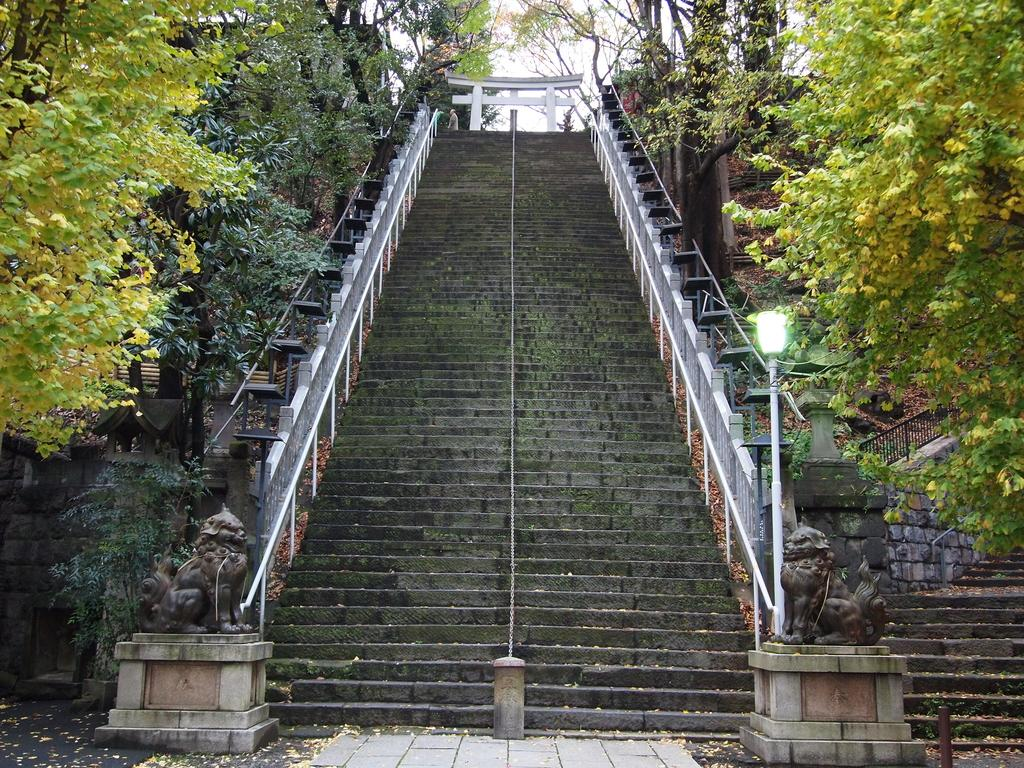What type of structure can be seen in the image? There are stairs in the image, which suggests a building or multi-level structure. What material is used for the rods in the image? Iron rods are present in the image. What is the purpose of the pole in the image? The pole's purpose is not explicitly stated, but it could be for support or decoration. What is the source of light in the image? A light is visible in the image. What type of vegetation is present in the image? Trees are present in the image. What type of artwork is in the image? Sculptures are in the image. What architectural feature is present in the image? There is an arch in the image. What is visible in the background of the image? The sky is visible in the background of the image. How does the camera capture the image? There is no camera present in the image; it is a static representation of the scene. What type of fuel is being burned in the image? There is no indication of any burning or fuel in the image. 